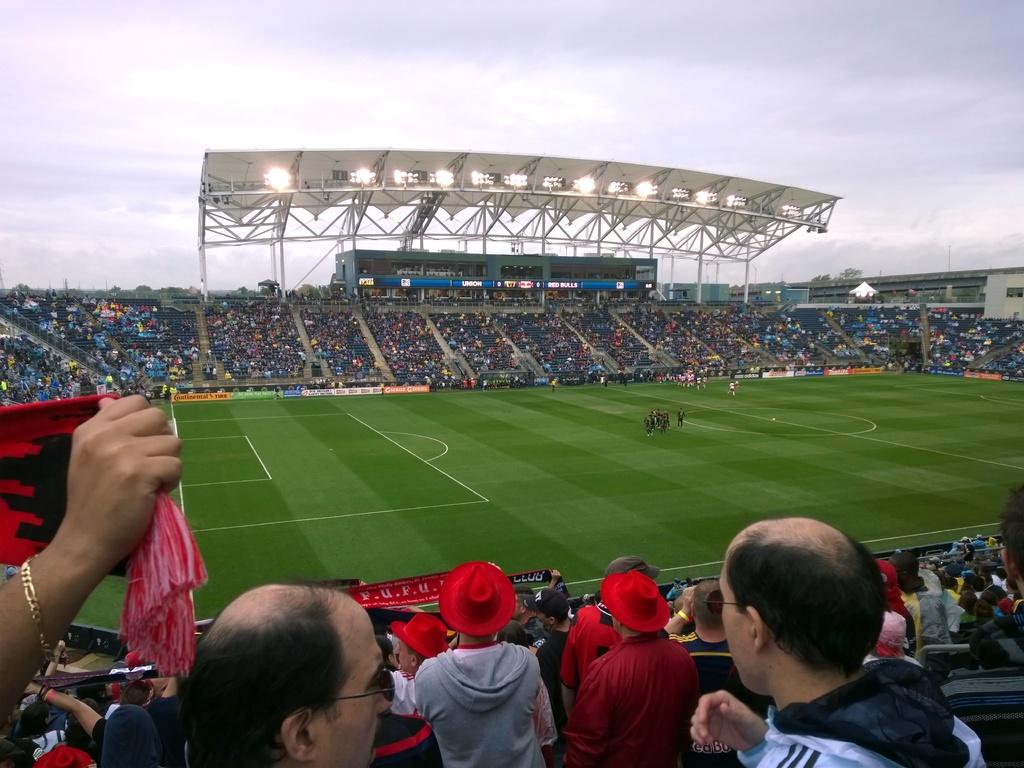Where was the image taken? The image was taken at a stadium. What is happening on the ground in the image? There are players on the ground in the image. Who is present in the image besides the players? There is an audience at the bottom of the image. What can be seen in the background of the image? The sky is visible in the background of the image. How many children are sitting on top of the stadium in the image? There are no children sitting on top of the stadium in the image. What type of class is being taught in the image? There is no class being taught in the image; it is a sports event taking place at a stadium. 